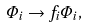Convert formula to latex. <formula><loc_0><loc_0><loc_500><loc_500>\Phi _ { i } \rightarrow f _ { i } \Phi _ { i } ,</formula> 